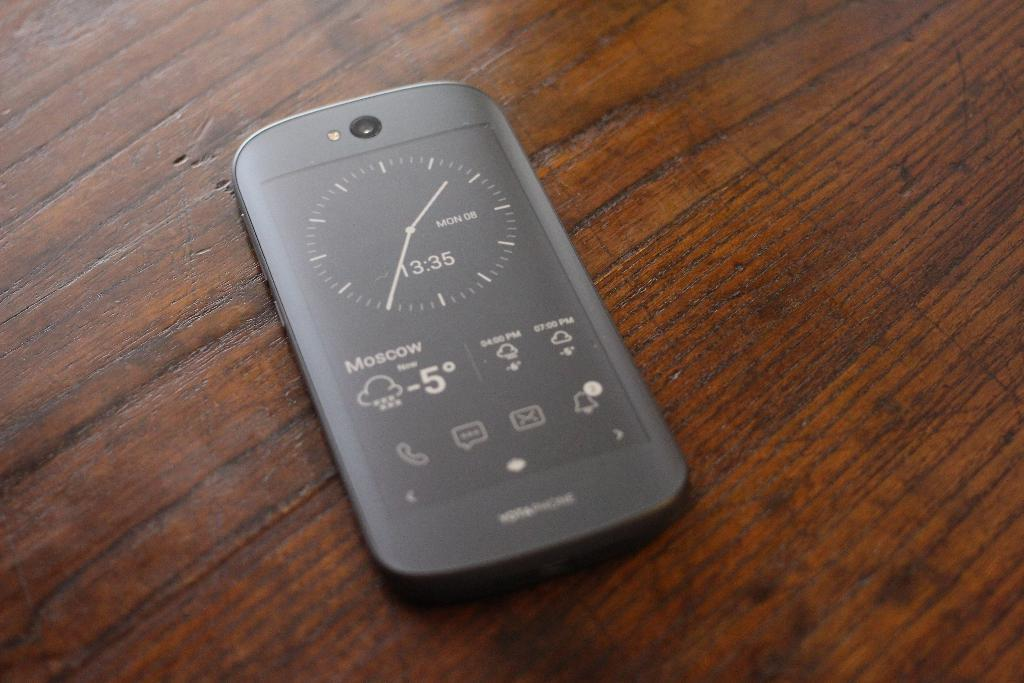What electronic device is visible in the image? There is a mobile phone in the image. Where is the mobile phone located? The mobile phone is kept on a table. What flavor of cloth can be seen draped over the mobile phone in the image? There is no cloth draped over the mobile phone in the image, and therefore no flavor can be associated with it. 